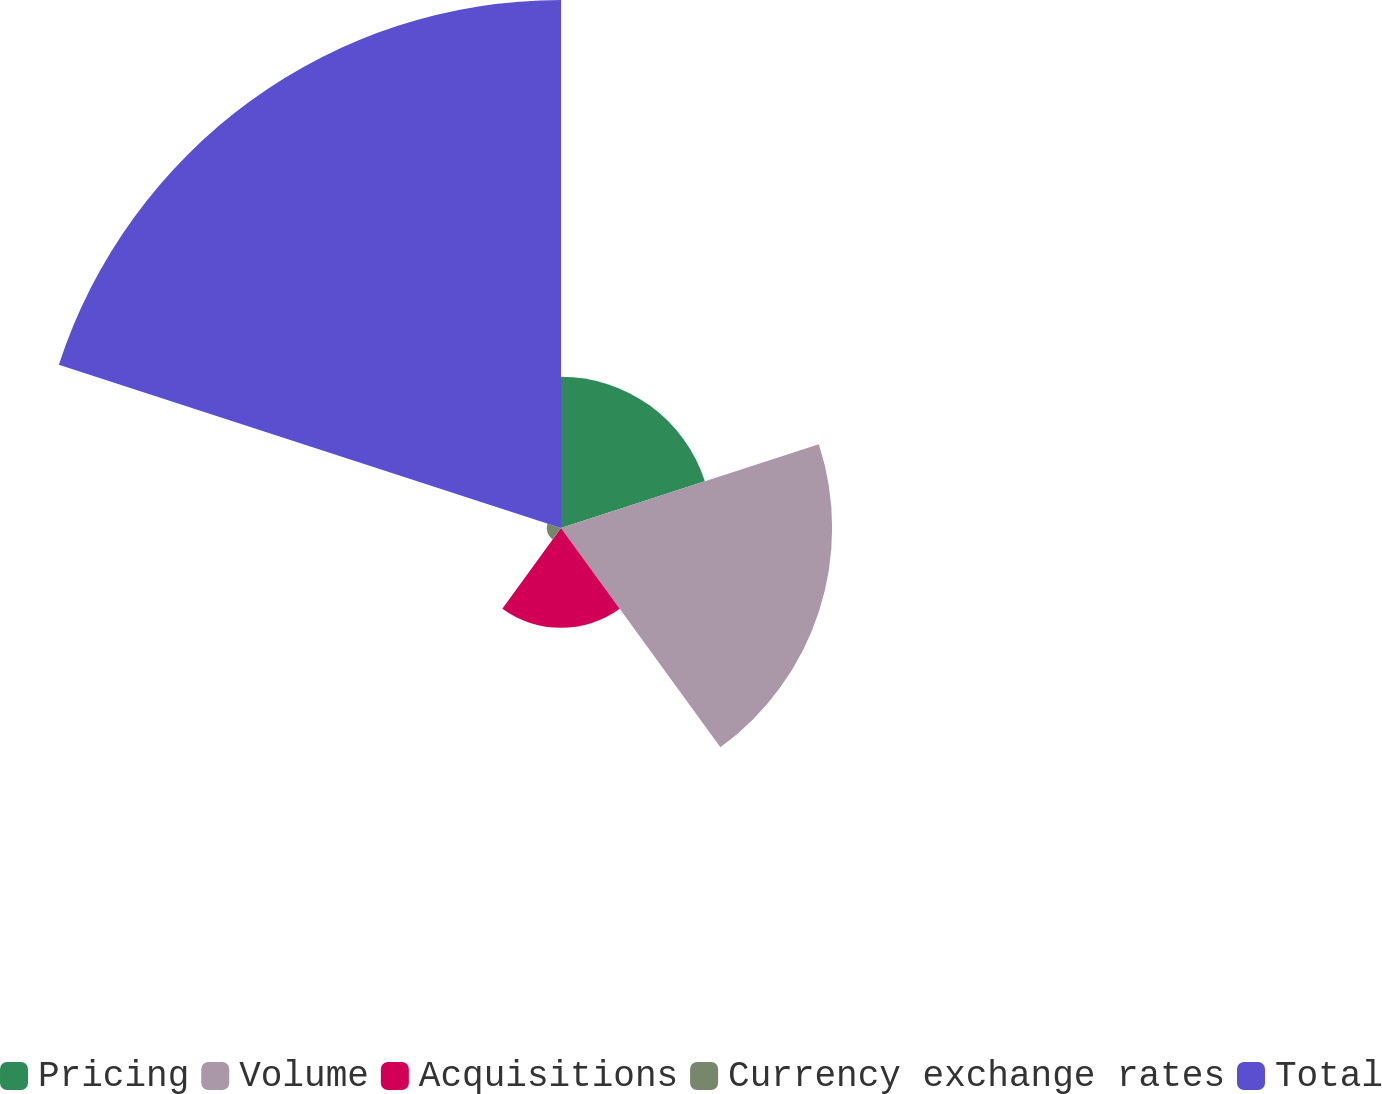Convert chart to OTSL. <chart><loc_0><loc_0><loc_500><loc_500><pie_chart><fcel>Pricing<fcel>Volume<fcel>Acquisitions<fcel>Currency exchange rates<fcel>Total<nl><fcel>14.21%<fcel>25.47%<fcel>9.38%<fcel>1.34%<fcel>49.6%<nl></chart> 